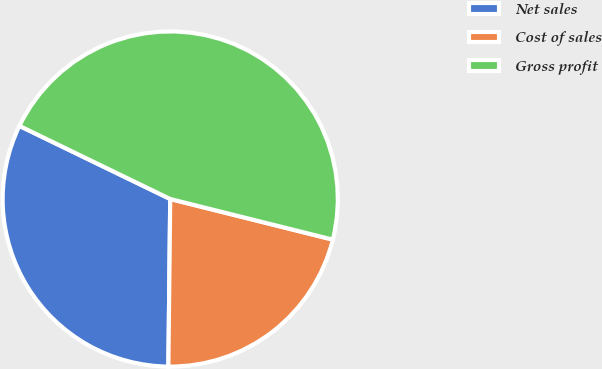Convert chart. <chart><loc_0><loc_0><loc_500><loc_500><pie_chart><fcel>Net sales<fcel>Cost of sales<fcel>Gross profit<nl><fcel>32.01%<fcel>21.28%<fcel>46.71%<nl></chart> 